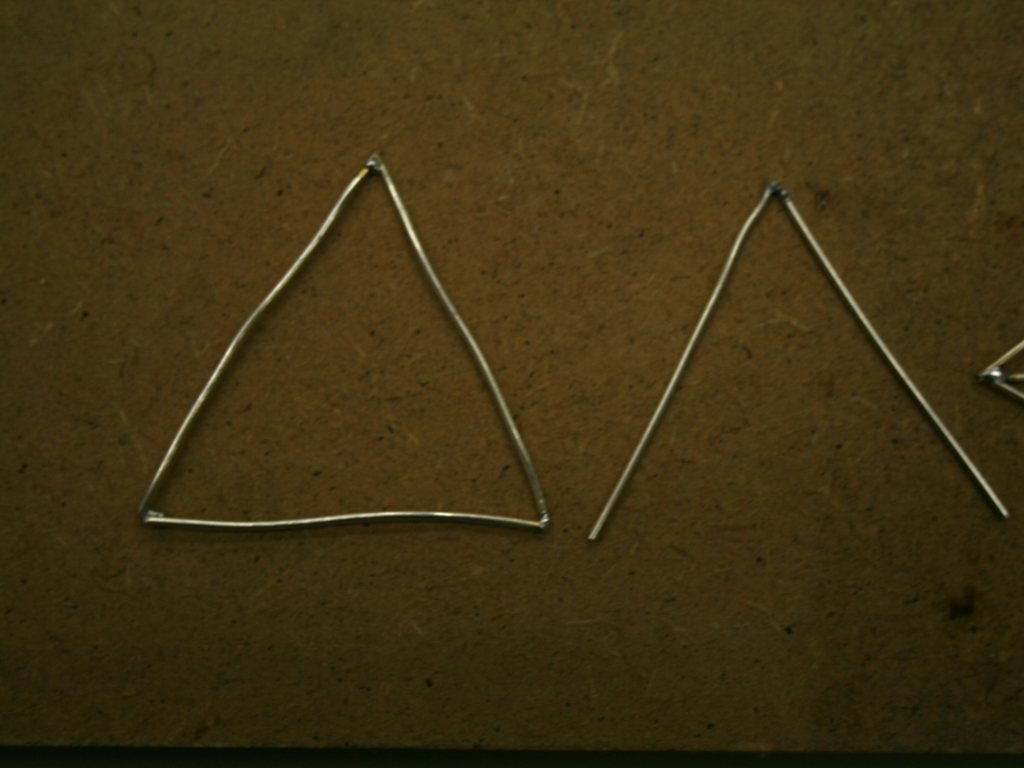What is the quality of this image?
A. poor
B. average
C. below average While the image is clear enough to discern details, such as the shape and placement of the wireframes, the overall quality can be described as average due to the lack of sharpness, lighting that appears flat, and the presence of grain. Additionally, the composition of the photo is simple, and there is no significant detail that stands out, contributing to its average rating. 